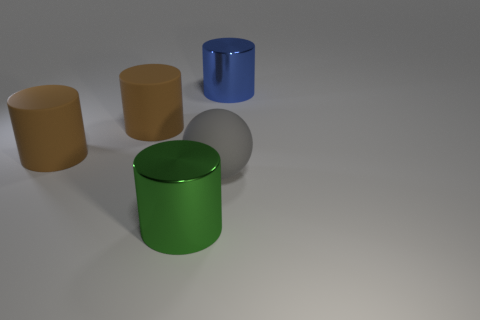Subtract 1 cylinders. How many cylinders are left? 3 Add 4 large yellow matte things. How many objects exist? 9 Subtract all cylinders. How many objects are left? 1 Add 4 matte spheres. How many matte spheres are left? 5 Add 5 rubber objects. How many rubber objects exist? 8 Subtract 0 cyan cylinders. How many objects are left? 5 Subtract all small yellow shiny cylinders. Subtract all green shiny cylinders. How many objects are left? 4 